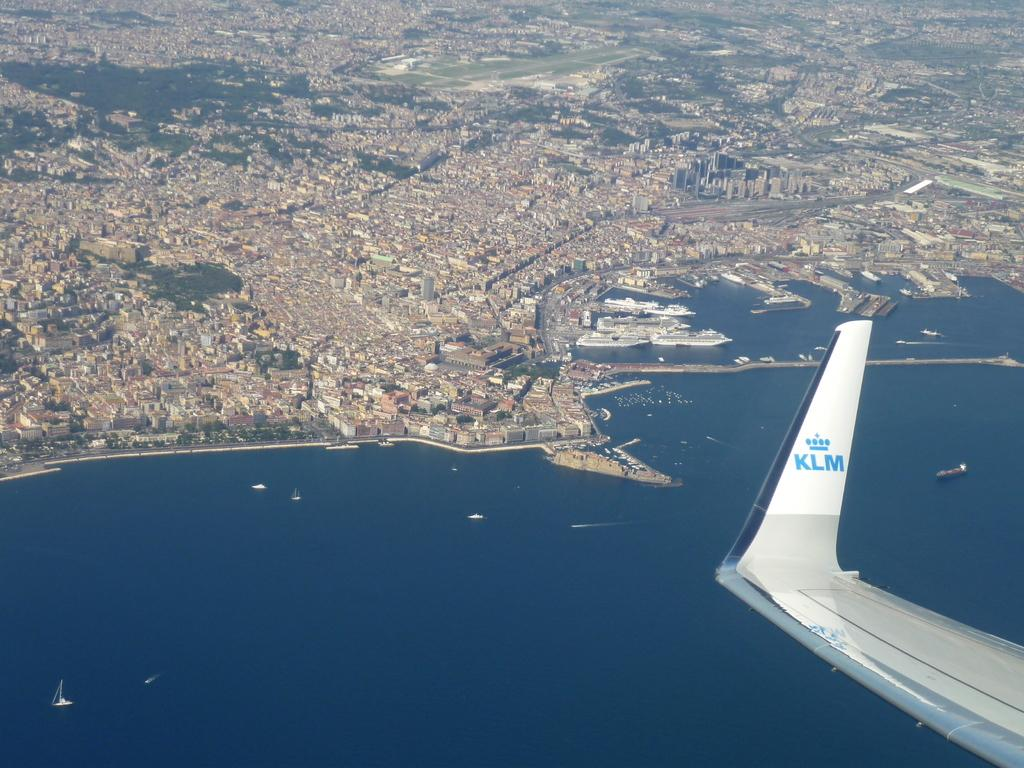<image>
Write a terse but informative summary of the picture. Wing of an airplane with the letters KLM on it. 